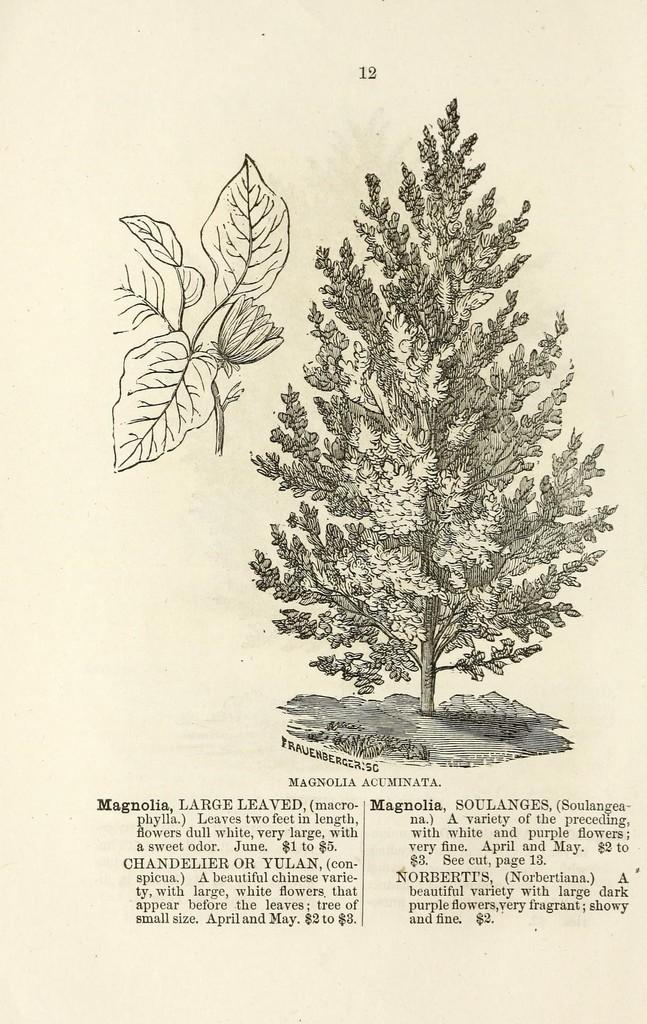What is the main subject of the image? The main subject of the image is a page. What can be found on the page? The page contains an image of a horsetail plant. How much income does the jar on the page generate? There is no jar present on the page, and therefore no income can be associated with it. 